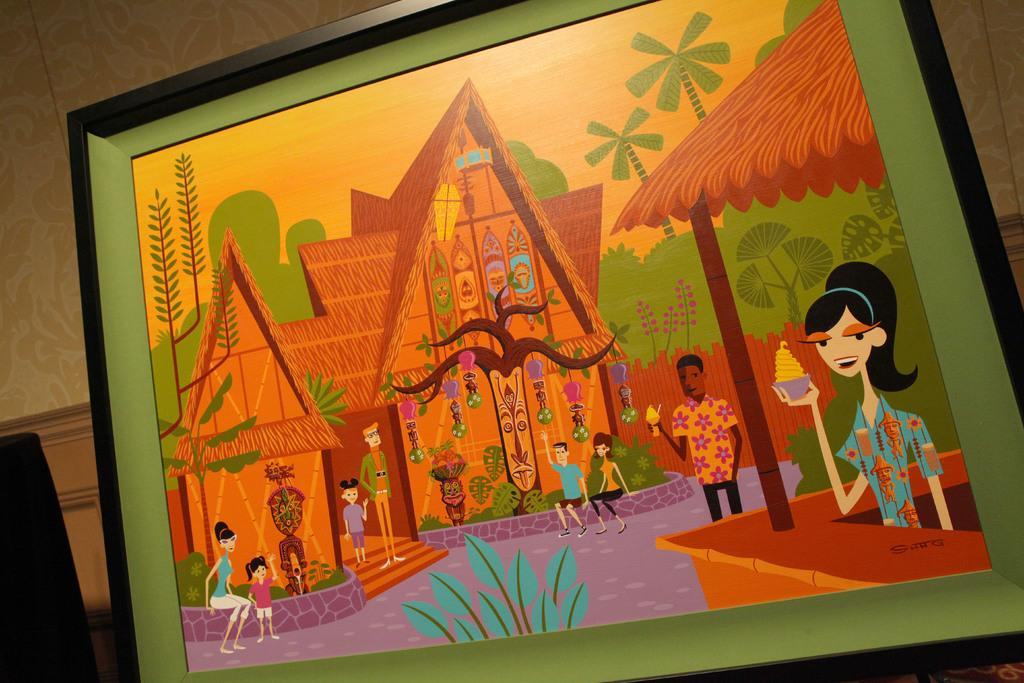What is the main object in the image? There is a frame in the image. What is inside the frame? The frame contains a painting. What is depicted in the painting? The painting depicts people and leaves. What can be seen behind the frame? There is a wall visible behind the frame. How many ladybugs are crawling on the leaves in the painting? There are no ladybugs visible in the painting; it depicts people and leaves. Can you tell me which person in the painting is the dad? There is no information about the relationships between the people depicted in the painting, so it cannot be determined who the dad is. 